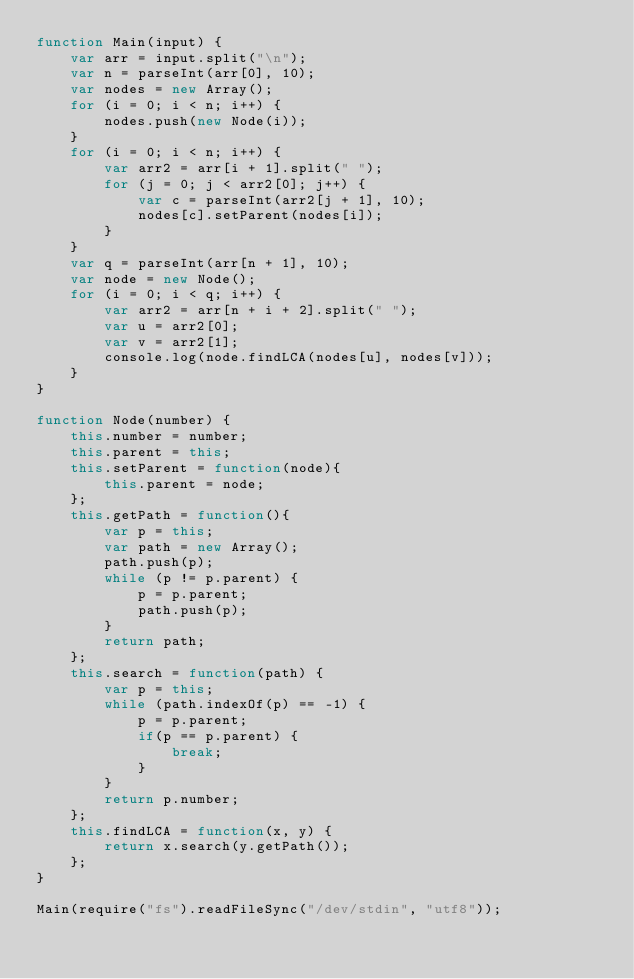<code> <loc_0><loc_0><loc_500><loc_500><_JavaScript_>function Main(input) {
    var arr = input.split("\n");
    var n = parseInt(arr[0], 10);
    var nodes = new Array();
    for (i = 0; i < n; i++) {
        nodes.push(new Node(i));
    }
    for (i = 0; i < n; i++) {
        var arr2 = arr[i + 1].split(" ");
        for (j = 0; j < arr2[0]; j++) {
            var c = parseInt(arr2[j + 1], 10);
            nodes[c].setParent(nodes[i]);
        }
    }
    var q = parseInt(arr[n + 1], 10);
    var node = new Node();
    for (i = 0; i < q; i++) {
        var arr2 = arr[n + i + 2].split(" ");
        var u = arr2[0];
        var v = arr2[1];
        console.log(node.findLCA(nodes[u], nodes[v]));
    }
}

function Node(number) {
    this.number = number;
    this.parent = this;
    this.setParent = function(node){
        this.parent = node;
    };
    this.getPath = function(){
        var p = this;
        var path = new Array();
        path.push(p);
        while (p != p.parent) {
            p = p.parent;
            path.push(p);
        }
        return path;
    };
    this.search = function(path) {
        var p = this;
        while (path.indexOf(p) == -1) {
            p = p.parent;
            if(p == p.parent) {
                break;
            }
        }
        return p.number;
    };
    this.findLCA = function(x, y) {
        return x.search(y.getPath());
    };
}

Main(require("fs").readFileSync("/dev/stdin", "utf8"));</code> 